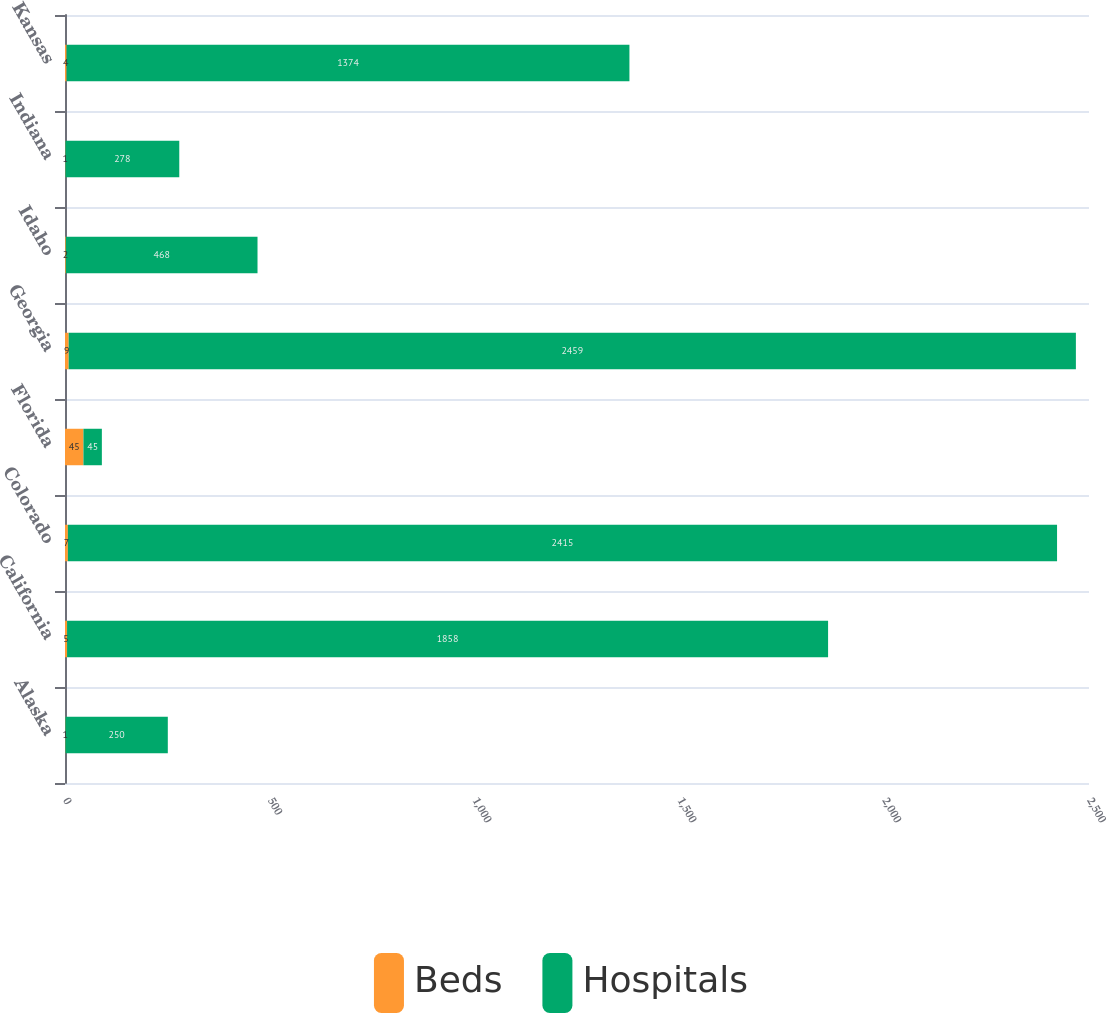Convert chart. <chart><loc_0><loc_0><loc_500><loc_500><stacked_bar_chart><ecel><fcel>Alaska<fcel>California<fcel>Colorado<fcel>Florida<fcel>Georgia<fcel>Idaho<fcel>Indiana<fcel>Kansas<nl><fcel>Beds<fcel>1<fcel>5<fcel>7<fcel>45<fcel>9<fcel>2<fcel>1<fcel>4<nl><fcel>Hospitals<fcel>250<fcel>1858<fcel>2415<fcel>45<fcel>2459<fcel>468<fcel>278<fcel>1374<nl></chart> 